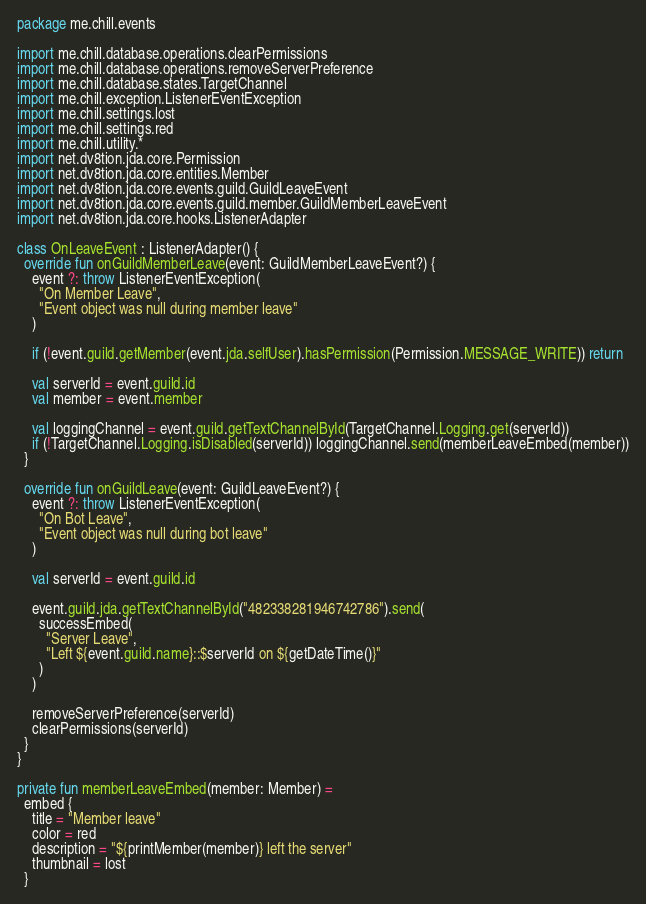<code> <loc_0><loc_0><loc_500><loc_500><_Kotlin_>package me.chill.events

import me.chill.database.operations.clearPermissions
import me.chill.database.operations.removeServerPreference
import me.chill.database.states.TargetChannel
import me.chill.exception.ListenerEventException
import me.chill.settings.lost
import me.chill.settings.red
import me.chill.utility.*
import net.dv8tion.jda.core.Permission
import net.dv8tion.jda.core.entities.Member
import net.dv8tion.jda.core.events.guild.GuildLeaveEvent
import net.dv8tion.jda.core.events.guild.member.GuildMemberLeaveEvent
import net.dv8tion.jda.core.hooks.ListenerAdapter

class OnLeaveEvent : ListenerAdapter() {
  override fun onGuildMemberLeave(event: GuildMemberLeaveEvent?) {
    event ?: throw ListenerEventException(
      "On Member Leave",
      "Event object was null during member leave"
    )

    if (!event.guild.getMember(event.jda.selfUser).hasPermission(Permission.MESSAGE_WRITE)) return

    val serverId = event.guild.id
    val member = event.member

    val loggingChannel = event.guild.getTextChannelById(TargetChannel.Logging.get(serverId))
    if (!TargetChannel.Logging.isDisabled(serverId)) loggingChannel.send(memberLeaveEmbed(member))
  }

  override fun onGuildLeave(event: GuildLeaveEvent?) {
    event ?: throw ListenerEventException(
      "On Bot Leave",
      "Event object was null during bot leave"
    )

    val serverId = event.guild.id

    event.guild.jda.getTextChannelById("482338281946742786").send(
      successEmbed(
        "Server Leave",
        "Left ${event.guild.name}::$serverId on ${getDateTime()}"
      )
    )

    removeServerPreference(serverId)
    clearPermissions(serverId)
  }
}

private fun memberLeaveEmbed(member: Member) =
  embed {
    title = "Member leave"
    color = red
    description = "${printMember(member)} left the server"
    thumbnail = lost
  }</code> 